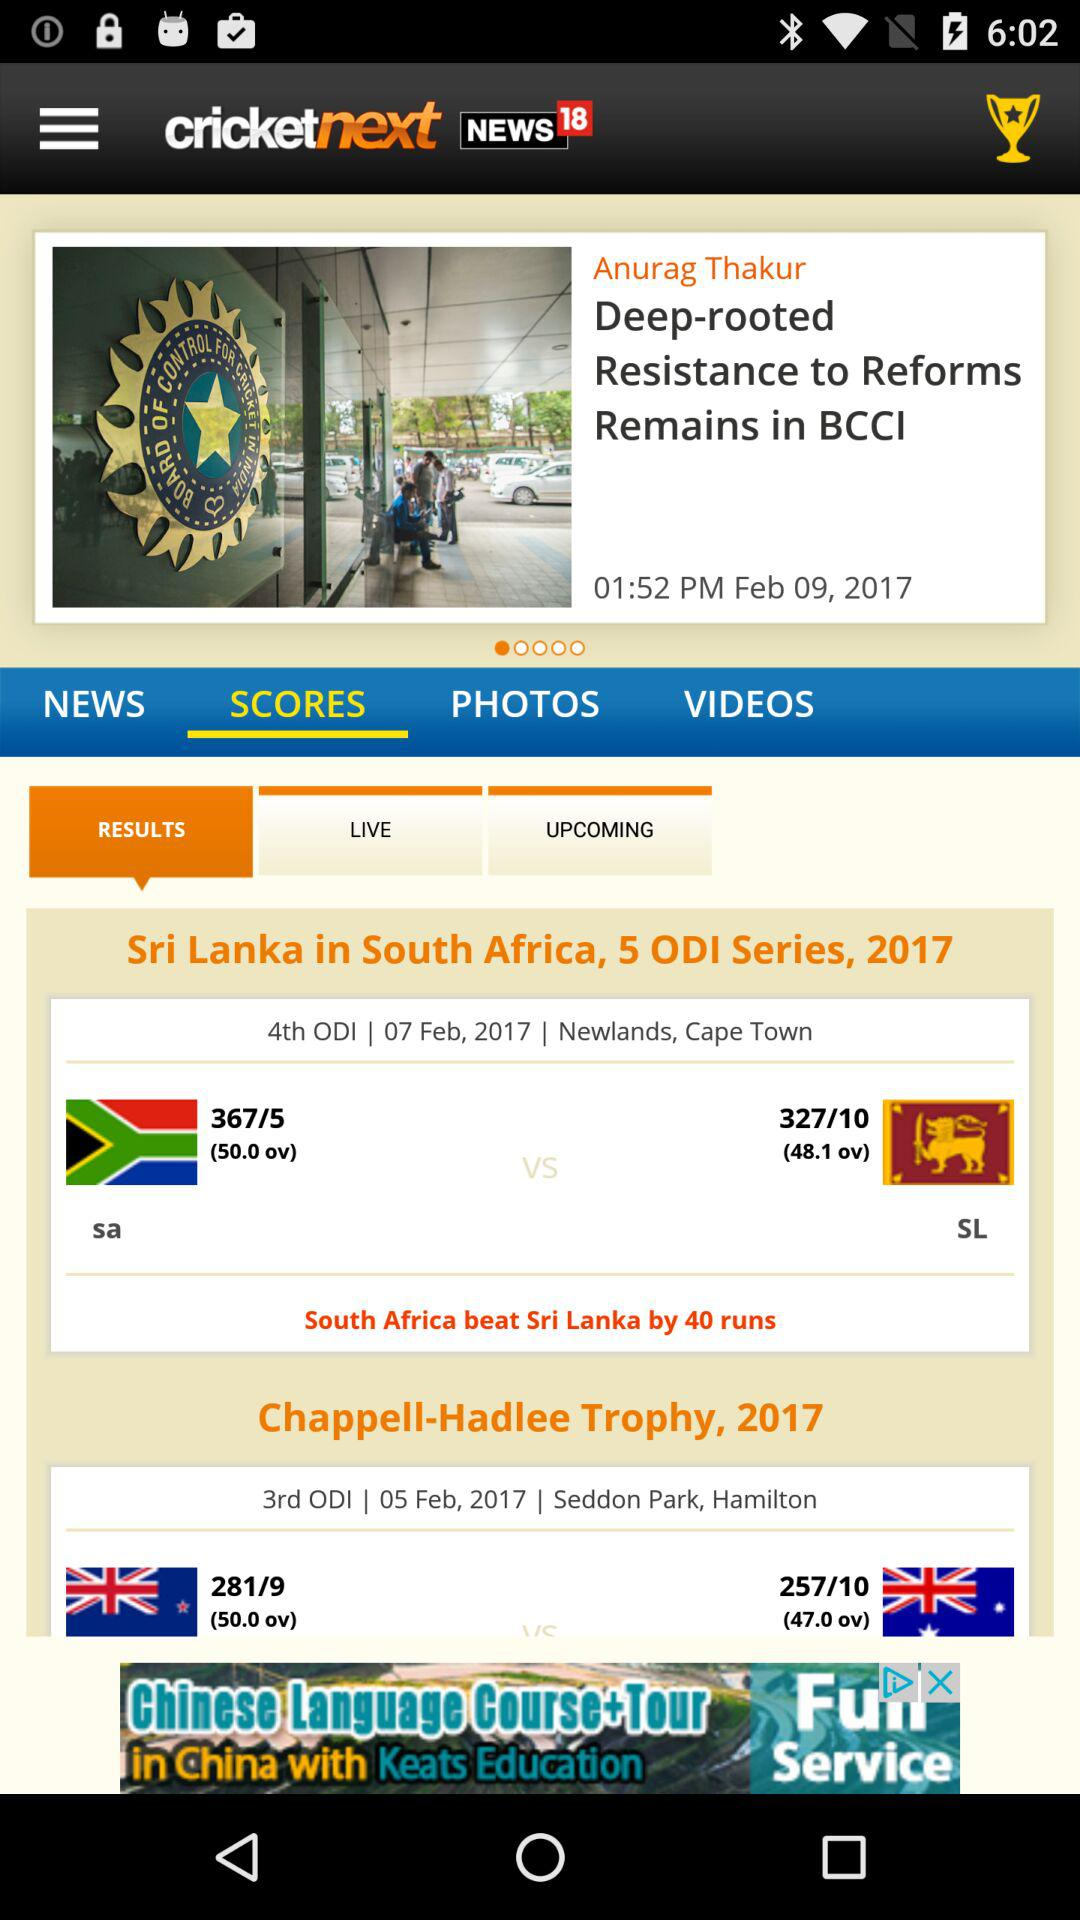How many runs did South Africa score? South Africa scored 367 runs. 